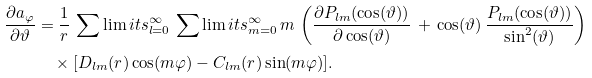<formula> <loc_0><loc_0><loc_500><loc_500>\frac { \partial a _ { \varphi } } { \partial \vartheta } & = \frac { 1 } { r } \, \sum \lim i t s _ { l = 0 } ^ { \infty } \, \sum \lim i t s _ { m = 0 } ^ { \infty } \, m \, \left ( \frac { \partial P _ { l m } ( \cos ( \vartheta ) ) } { \partial \cos ( \vartheta ) } \, + \, \cos ( \vartheta ) \, \frac { P _ { l m } ( \cos ( \vartheta ) ) } { \sin ^ { 2 } ( \vartheta ) } \right ) \\ & \quad \times [ D _ { l m } ( r ) \cos ( m \varphi ) - C _ { l m } ( r ) \sin ( m \varphi ) ] .</formula> 